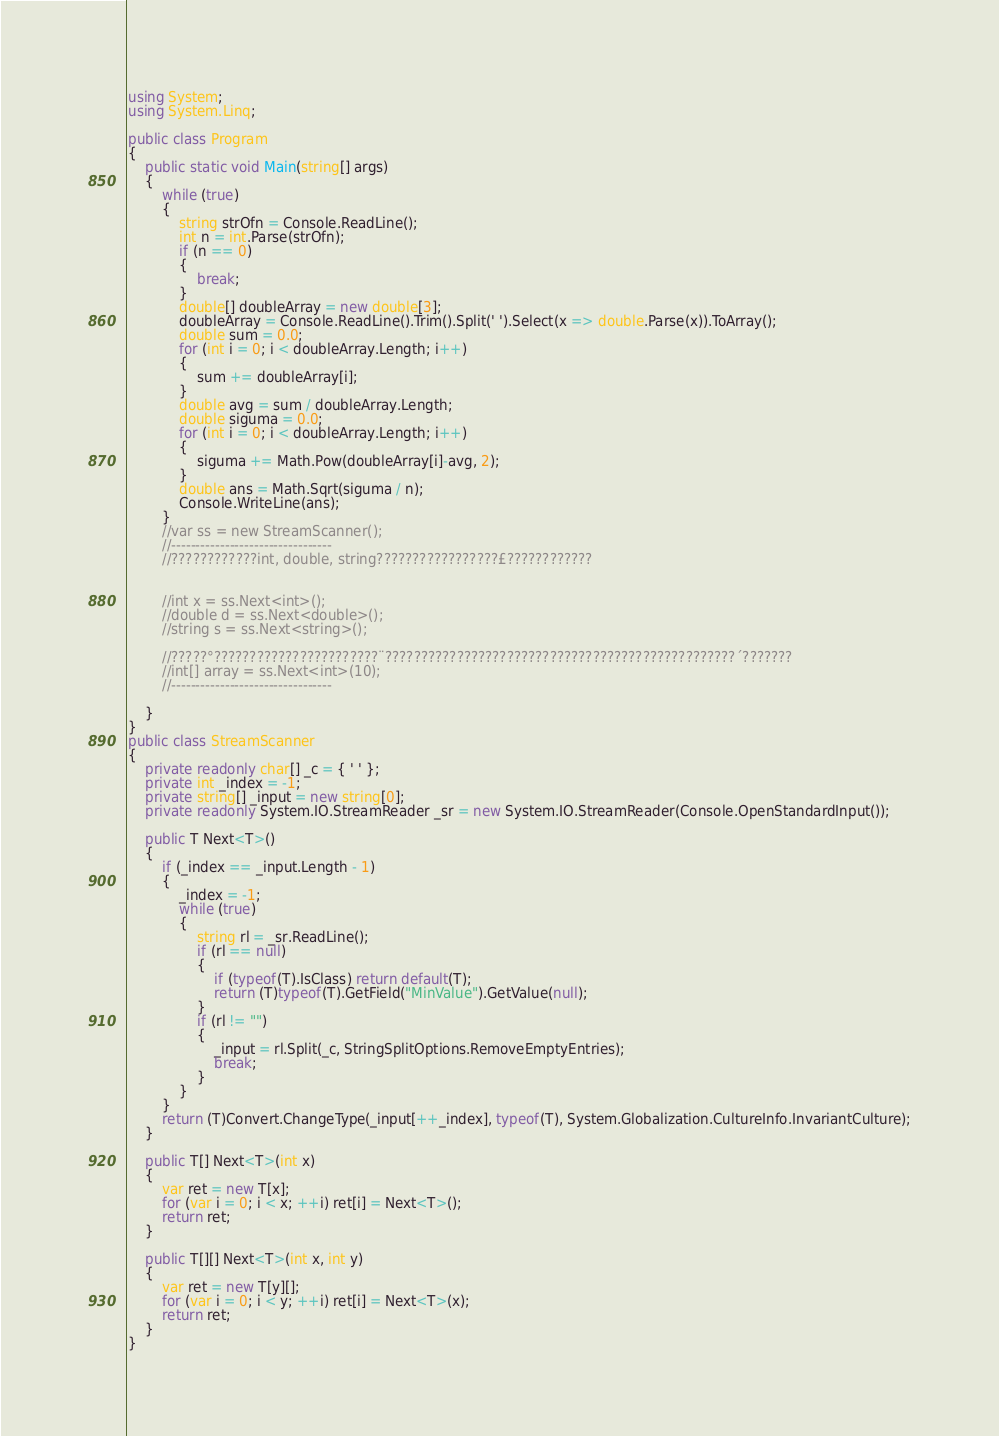<code> <loc_0><loc_0><loc_500><loc_500><_C#_>using System;
using System.Linq;

public class Program
{
	public static void Main(string[] args)
	{
		while (true)
		{
			string strOfn = Console.ReadLine();
			int n = int.Parse(strOfn);
			if (n == 0)
			{
				break;
			}
			double[] doubleArray = new double[3];
			doubleArray = Console.ReadLine().Trim().Split(' ').Select(x => double.Parse(x)).ToArray();
			double sum = 0.0;
			for (int i = 0; i < doubleArray.Length; i++)
			{
				sum += doubleArray[i];
			}
			double avg = sum / doubleArray.Length;
			double siguma = 0.0;
			for (int i = 0; i < doubleArray.Length; i++)
			{
				siguma += Math.Pow(doubleArray[i]-avg, 2);
			}
			double ans = Math.Sqrt(siguma / n);
			Console.WriteLine(ans);
		}
		//var ss = new StreamScanner();
		//---------------------------------
		//????????????int, double, string?????????????????£????????????


		//int x = ss.Next<int>();
		//double d = ss.Next<double>();
		//string s = ss.Next<string>();

		//?????°???????????????????????¨?????????????????????????????????????????????????´???????
		//int[] array = ss.Next<int>(10);
		//---------------------------------

	}
}
public class StreamScanner
{
	private readonly char[] _c = { ' ' };
	private int _index = -1;
	private string[] _input = new string[0];
	private readonly System.IO.StreamReader _sr = new System.IO.StreamReader(Console.OpenStandardInput());

	public T Next<T>()
	{
		if (_index == _input.Length - 1)
		{
			_index = -1;
			while (true)
			{
				string rl = _sr.ReadLine();
				if (rl == null)
				{
					if (typeof(T).IsClass) return default(T);
					return (T)typeof(T).GetField("MinValue").GetValue(null);
				}
				if (rl != "")
				{
					_input = rl.Split(_c, StringSplitOptions.RemoveEmptyEntries);
					break;
				}
			}
		}
		return (T)Convert.ChangeType(_input[++_index], typeof(T), System.Globalization.CultureInfo.InvariantCulture);
	}

	public T[] Next<T>(int x)
	{
		var ret = new T[x];
		for (var i = 0; i < x; ++i) ret[i] = Next<T>();
		return ret;
	}

	public T[][] Next<T>(int x, int y)
	{
		var ret = new T[y][];
		for (var i = 0; i < y; ++i) ret[i] = Next<T>(x);
		return ret;
	}
}</code> 